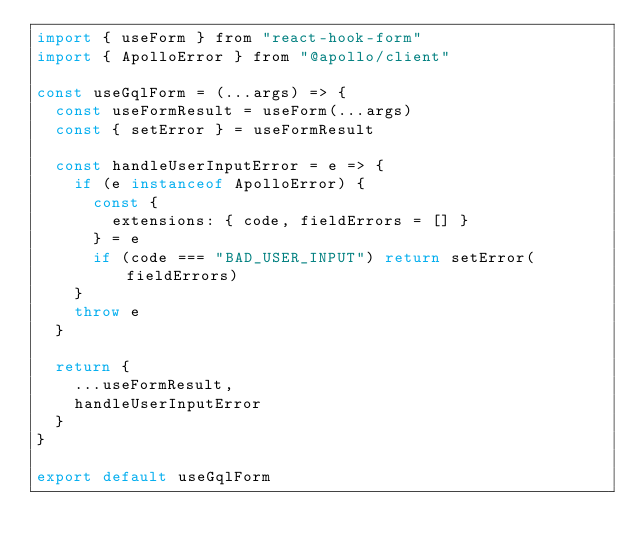<code> <loc_0><loc_0><loc_500><loc_500><_JavaScript_>import { useForm } from "react-hook-form"
import { ApolloError } from "@apollo/client"

const useGqlForm = (...args) => {
  const useFormResult = useForm(...args)
  const { setError } = useFormResult

  const handleUserInputError = e => {
    if (e instanceof ApolloError) {
      const {
        extensions: { code, fieldErrors = [] }
      } = e
      if (code === "BAD_USER_INPUT") return setError(fieldErrors)
    }
    throw e
  }

  return {
    ...useFormResult,
    handleUserInputError
  }
}

export default useGqlForm
</code> 